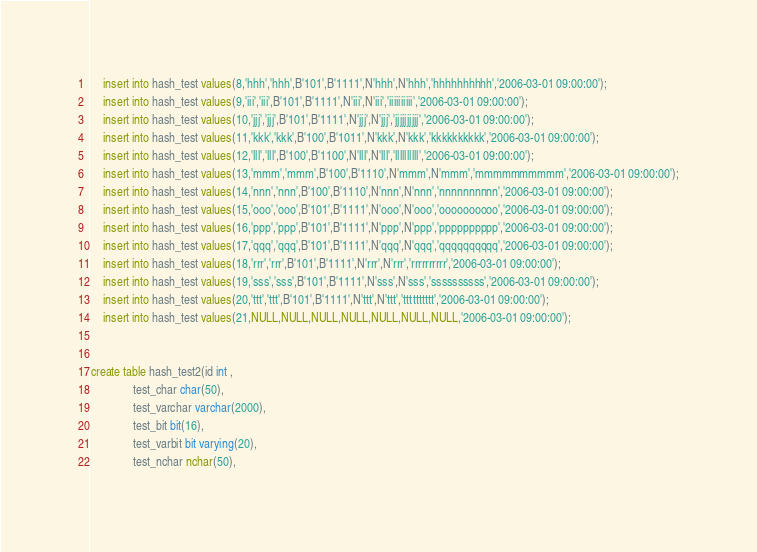<code> <loc_0><loc_0><loc_500><loc_500><_SQL_>	insert into hash_test values(8,'hhh','hhh',B'101',B'1111',N'hhh',N'hhh','hhhhhhhhhh','2006-03-01 09:00:00');
	insert into hash_test values(9,'iii','iii',B'101',B'1111',N'iii',N'iii','iiiiiiiiii','2006-03-01 09:00:00');
	insert into hash_test values(10,'jjj','jjj',B'101',B'1111',N'jjj',N'jjj','jjjjjjjjjj','2006-03-01 09:00:00');
	insert into hash_test values(11,'kkk','kkk',B'100',B'1011',N'kkk',N'kkk','kkkkkkkkkk','2006-03-01 09:00:00');
	insert into hash_test values(12,'lll','lll',B'100',B'1100',N'lll',N'lll','llllllllll','2006-03-01 09:00:00');
	insert into hash_test values(13,'mmm','mmm',B'100',B'1110',N'mmm',N'mmm','mmmmmmmmmm','2006-03-01 09:00:00');
	insert into hash_test values(14,'nnn','nnn',B'100',B'1110',N'nnn',N'nnn','nnnnnnnnnn','2006-03-01 09:00:00');
	insert into hash_test values(15,'ooo','ooo',B'101',B'1111',N'ooo',N'ooo','oooooooooo','2006-03-01 09:00:00');
	insert into hash_test values(16,'ppp','ppp',B'101',B'1111',N'ppp',N'ppp','pppppppppp','2006-03-01 09:00:00');
	insert into hash_test values(17,'qqq','qqq',B'101',B'1111',N'qqq',N'qqq','qqqqqqqqqq','2006-03-01 09:00:00');
	insert into hash_test values(18,'rrr','rrr',B'101',B'1111',N'rrr',N'rrr','rrrrrrrrrr','2006-03-01 09:00:00');
	insert into hash_test values(19,'sss','sss',B'101',B'1111',N'sss',N'sss','ssssssssss','2006-03-01 09:00:00');
	insert into hash_test values(20,'ttt','ttt',B'101',B'1111',N'ttt',N'ttt','tttttttttt','2006-03-01 09:00:00');
	insert into hash_test values(21,NULL,NULL,NULL,NULL,NULL,NULL,NULL,'2006-03-01 09:00:00');
	
	    
create table hash_test2(id int ,
			  test_char char(50),
			  test_varchar varchar(2000),
			  test_bit bit(16),           
			  test_varbit bit varying(20),       
			  test_nchar nchar(50),           </code> 